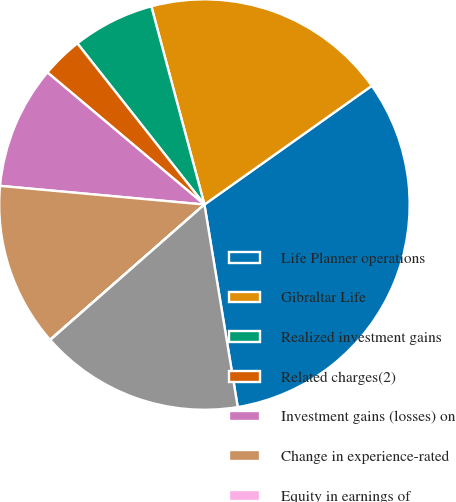<chart> <loc_0><loc_0><loc_500><loc_500><pie_chart><fcel>Life Planner operations<fcel>Gibraltar Life<fcel>Realized investment gains<fcel>Related charges(2)<fcel>Investment gains (losses) on<fcel>Change in experience-rated<fcel>Equity in earnings of<fcel>Income from continuing<nl><fcel>32.22%<fcel>19.34%<fcel>6.46%<fcel>3.24%<fcel>9.68%<fcel>12.9%<fcel>0.02%<fcel>16.12%<nl></chart> 